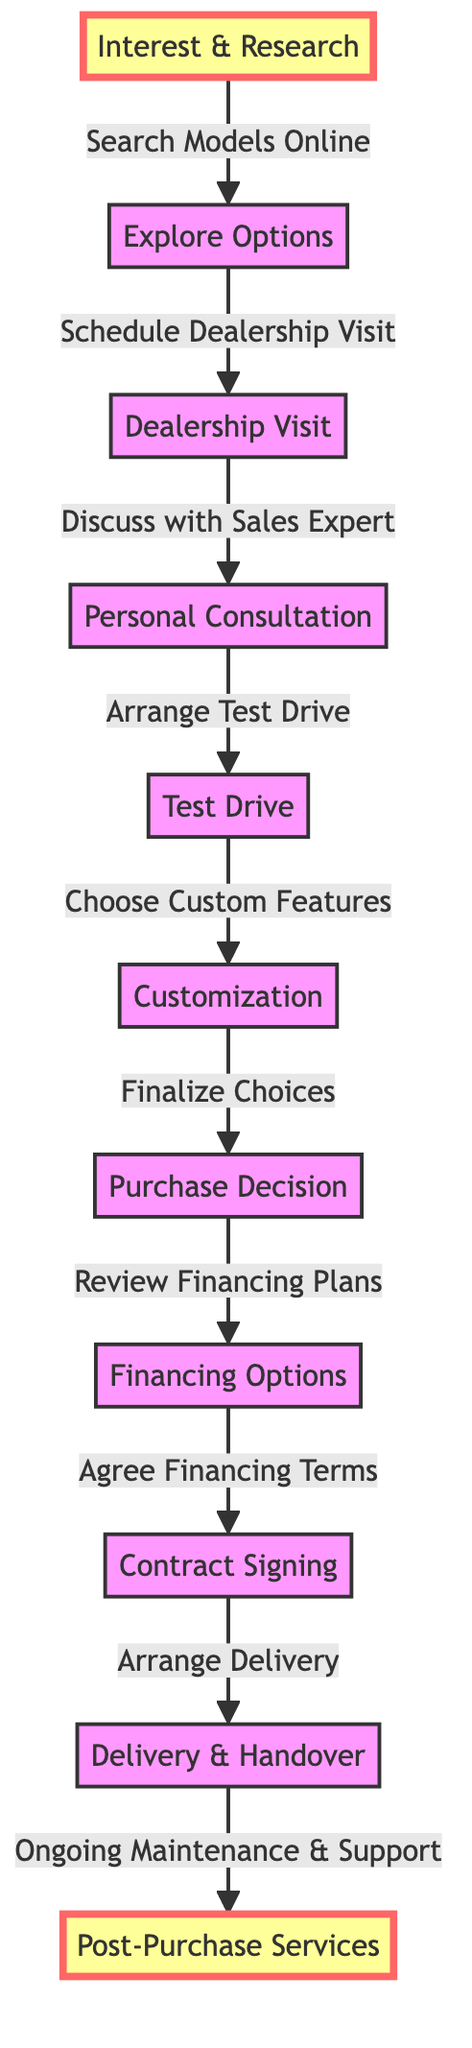What is the first step in the customer journey? The first step is represented by the node labeled "Interest & Research." It is the initial stage when customers start looking into luxury car options.
Answer: Interest & Research How many nodes are there in the diagram? By counting each distinct labeled stage or point, we find there are a total of 11 nodes listed in the diagram.
Answer: 11 What follows after "Customization"? Following "Customization," the next step is represented by the node labeled "Purchase Decision." This reflects that once customization is done, the customer makes a purchasing choice.
Answer: Purchase Decision What two nodes are connected by the edge labeled "Schedule Dealership Visit"? The edge "Schedule Dealership Visit" connects "Explore Options" to "Dealership Visit," indicating the transition from researching options to visiting the dealership.
Answer: Explore Options, Dealership Visit Which two steps occur before "Contract Signing"? The steps occurring before "Contract Signing" are "Financing Options" and "Purchase Decision." The individual must first consider financing options and finalize their choice before signing a contract.
Answer: Purchase Decision, Financing Options Is "Post-Purchase Services" a final step in the journey? Yes, "Post-Purchase Services" is the final step, as it follows "Delivery" and represents ongoing support after the car has been delivered.
Answer: Yes What is the relationship between "Test Drive" and "Customization"? The relationship is that "Test Drive" leads to "Customization," meaning the action of test-driving influences the choice of custom features for the luxury car.
Answer: Choose Custom Features Which node is highlighted in this diagram? The highlighted node is "Interest & Research." This indicates its importance in attracting initial interest in the customer journey.
Answer: Interest & Research What do the edges represent in this diagram? The edges represent the relationships or transitions between different stages in the customer's journey toward purchasing a luxury vehicle.
Answer: Relationships Which step comes immediately after "Agree Financing Terms"? The next step that follows "Agree Financing Terms" is "Contract Signing," indicating the process of finalizing the purchase agreement.
Answer: Contract Signing 